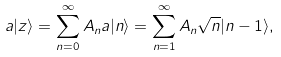<formula> <loc_0><loc_0><loc_500><loc_500>a | z \rangle = \sum _ { n = 0 } ^ { \infty } A _ { n } a | n \rangle = \sum _ { n = 1 } ^ { \infty } A _ { n } \sqrt { n } | n - 1 \rangle ,</formula> 